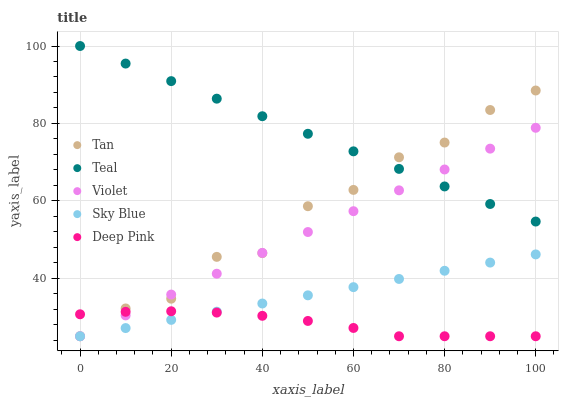Does Deep Pink have the minimum area under the curve?
Answer yes or no. Yes. Does Teal have the maximum area under the curve?
Answer yes or no. Yes. Does Tan have the minimum area under the curve?
Answer yes or no. No. Does Tan have the maximum area under the curve?
Answer yes or no. No. Is Teal the smoothest?
Answer yes or no. Yes. Is Tan the roughest?
Answer yes or no. Yes. Is Deep Pink the smoothest?
Answer yes or no. No. Is Deep Pink the roughest?
Answer yes or no. No. Does Sky Blue have the lowest value?
Answer yes or no. Yes. Does Teal have the lowest value?
Answer yes or no. No. Does Teal have the highest value?
Answer yes or no. Yes. Does Tan have the highest value?
Answer yes or no. No. Is Sky Blue less than Teal?
Answer yes or no. Yes. Is Teal greater than Sky Blue?
Answer yes or no. Yes. Does Violet intersect Deep Pink?
Answer yes or no. Yes. Is Violet less than Deep Pink?
Answer yes or no. No. Is Violet greater than Deep Pink?
Answer yes or no. No. Does Sky Blue intersect Teal?
Answer yes or no. No. 